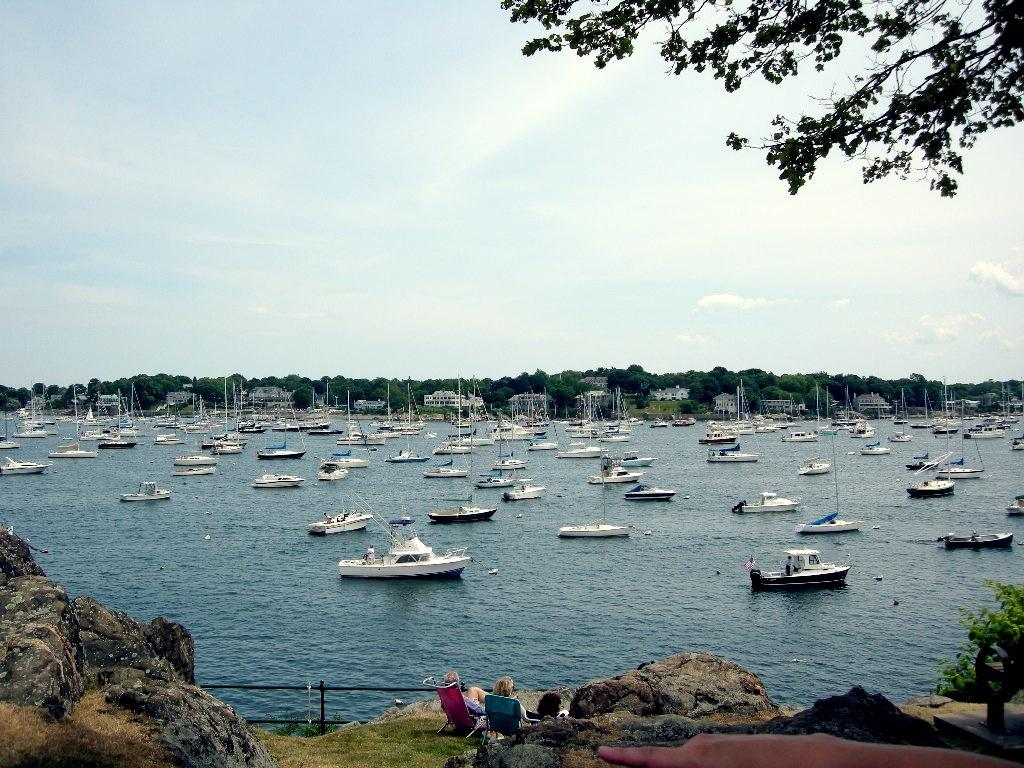What is the main subject of the image? The main subject of the image is a group of boats. Where are the boats located? The boats are on water. Can you describe the people visible in the image? There are people visible in the image, but their specific actions or roles are not clear. What type of natural environment is present in the image? There are trees in the image, indicating a natural environment. What is visible in the background of the image? The sky is visible in the background of the image. What is the profit margin of the boats in the image? There is no information about the profit margin of the boats in the image, as it is not relevant to the visual content. 